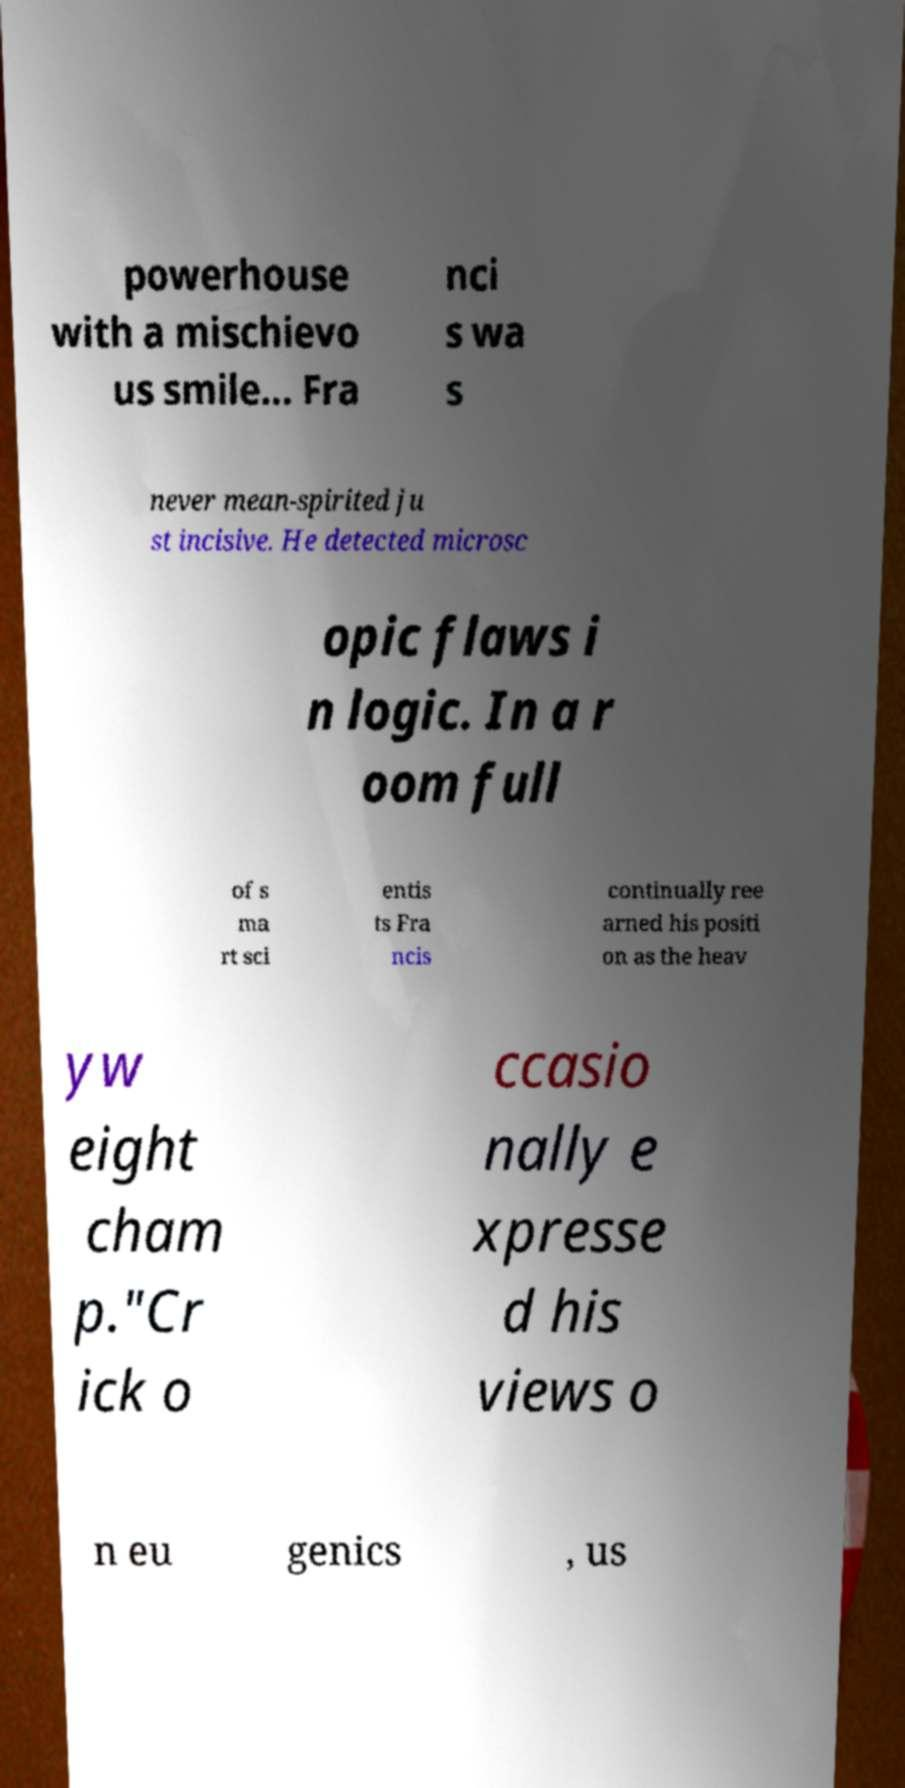For documentation purposes, I need the text within this image transcribed. Could you provide that? powerhouse with a mischievo us smile... Fra nci s wa s never mean-spirited ju st incisive. He detected microsc opic flaws i n logic. In a r oom full of s ma rt sci entis ts Fra ncis continually ree arned his positi on as the heav yw eight cham p."Cr ick o ccasio nally e xpresse d his views o n eu genics , us 